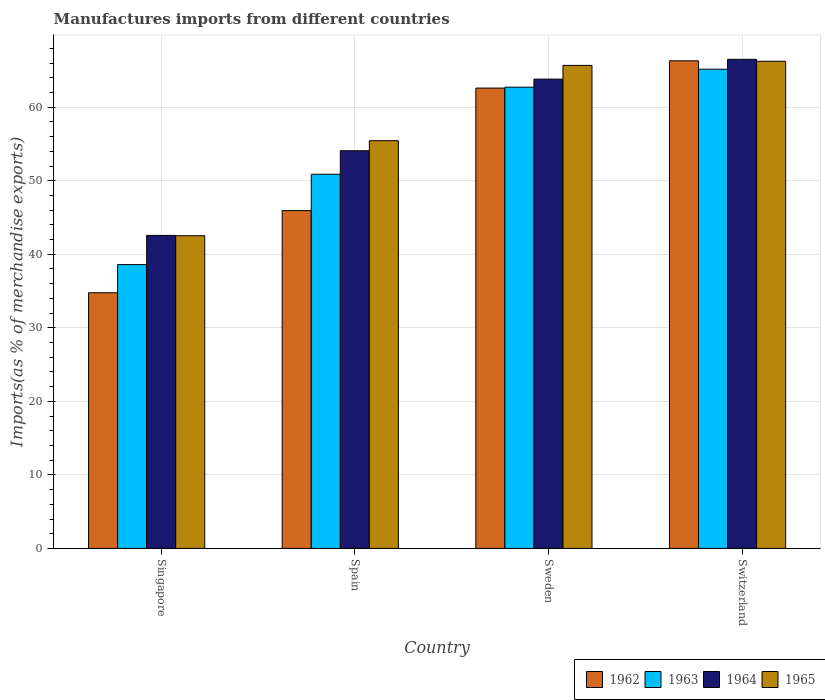How many different coloured bars are there?
Give a very brief answer. 4. How many groups of bars are there?
Your answer should be very brief. 4. Are the number of bars per tick equal to the number of legend labels?
Provide a succinct answer. Yes. How many bars are there on the 4th tick from the left?
Give a very brief answer. 4. How many bars are there on the 4th tick from the right?
Your answer should be compact. 4. What is the label of the 4th group of bars from the left?
Give a very brief answer. Switzerland. In how many cases, is the number of bars for a given country not equal to the number of legend labels?
Provide a short and direct response. 0. What is the percentage of imports to different countries in 1965 in Sweden?
Ensure brevity in your answer.  65.68. Across all countries, what is the maximum percentage of imports to different countries in 1962?
Make the answer very short. 66.31. Across all countries, what is the minimum percentage of imports to different countries in 1962?
Offer a terse response. 34.77. In which country was the percentage of imports to different countries in 1965 maximum?
Your response must be concise. Switzerland. In which country was the percentage of imports to different countries in 1964 minimum?
Ensure brevity in your answer.  Singapore. What is the total percentage of imports to different countries in 1963 in the graph?
Give a very brief answer. 217.37. What is the difference between the percentage of imports to different countries in 1963 in Spain and that in Switzerland?
Your answer should be compact. -14.28. What is the difference between the percentage of imports to different countries in 1964 in Singapore and the percentage of imports to different countries in 1963 in Spain?
Give a very brief answer. -8.32. What is the average percentage of imports to different countries in 1962 per country?
Keep it short and to the point. 52.4. What is the difference between the percentage of imports to different countries of/in 1965 and percentage of imports to different countries of/in 1964 in Singapore?
Your answer should be very brief. -0.04. In how many countries, is the percentage of imports to different countries in 1962 greater than 52 %?
Ensure brevity in your answer.  2. What is the ratio of the percentage of imports to different countries in 1962 in Singapore to that in Switzerland?
Your answer should be compact. 0.52. Is the percentage of imports to different countries in 1964 in Singapore less than that in Spain?
Offer a terse response. Yes. What is the difference between the highest and the second highest percentage of imports to different countries in 1964?
Make the answer very short. 12.43. What is the difference between the highest and the lowest percentage of imports to different countries in 1965?
Offer a very short reply. 23.72. In how many countries, is the percentage of imports to different countries in 1964 greater than the average percentage of imports to different countries in 1964 taken over all countries?
Your response must be concise. 2. Is the sum of the percentage of imports to different countries in 1964 in Singapore and Switzerland greater than the maximum percentage of imports to different countries in 1962 across all countries?
Provide a short and direct response. Yes. Is it the case that in every country, the sum of the percentage of imports to different countries in 1964 and percentage of imports to different countries in 1965 is greater than the sum of percentage of imports to different countries in 1963 and percentage of imports to different countries in 1962?
Your answer should be very brief. No. What does the 4th bar from the left in Sweden represents?
Offer a terse response. 1965. Are the values on the major ticks of Y-axis written in scientific E-notation?
Make the answer very short. No. How many legend labels are there?
Offer a terse response. 4. How are the legend labels stacked?
Provide a short and direct response. Horizontal. What is the title of the graph?
Make the answer very short. Manufactures imports from different countries. Does "1961" appear as one of the legend labels in the graph?
Provide a short and direct response. No. What is the label or title of the Y-axis?
Provide a short and direct response. Imports(as % of merchandise exports). What is the Imports(as % of merchandise exports) of 1962 in Singapore?
Offer a terse response. 34.77. What is the Imports(as % of merchandise exports) of 1963 in Singapore?
Make the answer very short. 38.6. What is the Imports(as % of merchandise exports) of 1964 in Singapore?
Provide a succinct answer. 42.56. What is the Imports(as % of merchandise exports) of 1965 in Singapore?
Your answer should be compact. 42.52. What is the Imports(as % of merchandise exports) of 1962 in Spain?
Offer a very short reply. 45.94. What is the Imports(as % of merchandise exports) in 1963 in Spain?
Your answer should be compact. 50.88. What is the Imports(as % of merchandise exports) of 1964 in Spain?
Offer a very short reply. 54.08. What is the Imports(as % of merchandise exports) of 1965 in Spain?
Provide a short and direct response. 55.44. What is the Imports(as % of merchandise exports) of 1962 in Sweden?
Ensure brevity in your answer.  62.6. What is the Imports(as % of merchandise exports) of 1963 in Sweden?
Offer a terse response. 62.72. What is the Imports(as % of merchandise exports) of 1964 in Sweden?
Ensure brevity in your answer.  63.82. What is the Imports(as % of merchandise exports) of 1965 in Sweden?
Provide a succinct answer. 65.68. What is the Imports(as % of merchandise exports) in 1962 in Switzerland?
Ensure brevity in your answer.  66.31. What is the Imports(as % of merchandise exports) of 1963 in Switzerland?
Provide a short and direct response. 65.16. What is the Imports(as % of merchandise exports) of 1964 in Switzerland?
Give a very brief answer. 66.51. What is the Imports(as % of merchandise exports) in 1965 in Switzerland?
Your response must be concise. 66.24. Across all countries, what is the maximum Imports(as % of merchandise exports) of 1962?
Provide a short and direct response. 66.31. Across all countries, what is the maximum Imports(as % of merchandise exports) in 1963?
Your answer should be very brief. 65.16. Across all countries, what is the maximum Imports(as % of merchandise exports) in 1964?
Your response must be concise. 66.51. Across all countries, what is the maximum Imports(as % of merchandise exports) in 1965?
Keep it short and to the point. 66.24. Across all countries, what is the minimum Imports(as % of merchandise exports) in 1962?
Offer a very short reply. 34.77. Across all countries, what is the minimum Imports(as % of merchandise exports) in 1963?
Your response must be concise. 38.6. Across all countries, what is the minimum Imports(as % of merchandise exports) in 1964?
Offer a very short reply. 42.56. Across all countries, what is the minimum Imports(as % of merchandise exports) of 1965?
Make the answer very short. 42.52. What is the total Imports(as % of merchandise exports) in 1962 in the graph?
Provide a succinct answer. 209.61. What is the total Imports(as % of merchandise exports) of 1963 in the graph?
Your response must be concise. 217.37. What is the total Imports(as % of merchandise exports) in 1964 in the graph?
Offer a terse response. 226.97. What is the total Imports(as % of merchandise exports) of 1965 in the graph?
Offer a very short reply. 229.89. What is the difference between the Imports(as % of merchandise exports) of 1962 in Singapore and that in Spain?
Offer a very short reply. -11.17. What is the difference between the Imports(as % of merchandise exports) in 1963 in Singapore and that in Spain?
Provide a short and direct response. -12.29. What is the difference between the Imports(as % of merchandise exports) in 1964 in Singapore and that in Spain?
Ensure brevity in your answer.  -11.51. What is the difference between the Imports(as % of merchandise exports) of 1965 in Singapore and that in Spain?
Your answer should be compact. -12.92. What is the difference between the Imports(as % of merchandise exports) in 1962 in Singapore and that in Sweden?
Provide a succinct answer. -27.83. What is the difference between the Imports(as % of merchandise exports) of 1963 in Singapore and that in Sweden?
Your answer should be very brief. -24.13. What is the difference between the Imports(as % of merchandise exports) in 1964 in Singapore and that in Sweden?
Make the answer very short. -21.25. What is the difference between the Imports(as % of merchandise exports) in 1965 in Singapore and that in Sweden?
Make the answer very short. -23.16. What is the difference between the Imports(as % of merchandise exports) in 1962 in Singapore and that in Switzerland?
Provide a succinct answer. -31.54. What is the difference between the Imports(as % of merchandise exports) of 1963 in Singapore and that in Switzerland?
Offer a terse response. -26.57. What is the difference between the Imports(as % of merchandise exports) of 1964 in Singapore and that in Switzerland?
Give a very brief answer. -23.94. What is the difference between the Imports(as % of merchandise exports) of 1965 in Singapore and that in Switzerland?
Your response must be concise. -23.72. What is the difference between the Imports(as % of merchandise exports) in 1962 in Spain and that in Sweden?
Your answer should be very brief. -16.66. What is the difference between the Imports(as % of merchandise exports) in 1963 in Spain and that in Sweden?
Your answer should be compact. -11.84. What is the difference between the Imports(as % of merchandise exports) of 1964 in Spain and that in Sweden?
Provide a short and direct response. -9.74. What is the difference between the Imports(as % of merchandise exports) of 1965 in Spain and that in Sweden?
Keep it short and to the point. -10.24. What is the difference between the Imports(as % of merchandise exports) in 1962 in Spain and that in Switzerland?
Offer a very short reply. -20.37. What is the difference between the Imports(as % of merchandise exports) of 1963 in Spain and that in Switzerland?
Keep it short and to the point. -14.28. What is the difference between the Imports(as % of merchandise exports) of 1964 in Spain and that in Switzerland?
Provide a short and direct response. -12.43. What is the difference between the Imports(as % of merchandise exports) of 1965 in Spain and that in Switzerland?
Give a very brief answer. -10.8. What is the difference between the Imports(as % of merchandise exports) in 1962 in Sweden and that in Switzerland?
Keep it short and to the point. -3.71. What is the difference between the Imports(as % of merchandise exports) in 1963 in Sweden and that in Switzerland?
Ensure brevity in your answer.  -2.44. What is the difference between the Imports(as % of merchandise exports) of 1964 in Sweden and that in Switzerland?
Your answer should be compact. -2.69. What is the difference between the Imports(as % of merchandise exports) in 1965 in Sweden and that in Switzerland?
Keep it short and to the point. -0.56. What is the difference between the Imports(as % of merchandise exports) of 1962 in Singapore and the Imports(as % of merchandise exports) of 1963 in Spain?
Provide a succinct answer. -16.11. What is the difference between the Imports(as % of merchandise exports) in 1962 in Singapore and the Imports(as % of merchandise exports) in 1964 in Spain?
Give a very brief answer. -19.31. What is the difference between the Imports(as % of merchandise exports) of 1962 in Singapore and the Imports(as % of merchandise exports) of 1965 in Spain?
Give a very brief answer. -20.68. What is the difference between the Imports(as % of merchandise exports) of 1963 in Singapore and the Imports(as % of merchandise exports) of 1964 in Spain?
Ensure brevity in your answer.  -15.48. What is the difference between the Imports(as % of merchandise exports) in 1963 in Singapore and the Imports(as % of merchandise exports) in 1965 in Spain?
Ensure brevity in your answer.  -16.85. What is the difference between the Imports(as % of merchandise exports) of 1964 in Singapore and the Imports(as % of merchandise exports) of 1965 in Spain?
Make the answer very short. -12.88. What is the difference between the Imports(as % of merchandise exports) of 1962 in Singapore and the Imports(as % of merchandise exports) of 1963 in Sweden?
Your answer should be very brief. -27.95. What is the difference between the Imports(as % of merchandise exports) of 1962 in Singapore and the Imports(as % of merchandise exports) of 1964 in Sweden?
Make the answer very short. -29.05. What is the difference between the Imports(as % of merchandise exports) of 1962 in Singapore and the Imports(as % of merchandise exports) of 1965 in Sweden?
Your response must be concise. -30.91. What is the difference between the Imports(as % of merchandise exports) of 1963 in Singapore and the Imports(as % of merchandise exports) of 1964 in Sweden?
Your response must be concise. -25.22. What is the difference between the Imports(as % of merchandise exports) in 1963 in Singapore and the Imports(as % of merchandise exports) in 1965 in Sweden?
Your answer should be compact. -27.09. What is the difference between the Imports(as % of merchandise exports) of 1964 in Singapore and the Imports(as % of merchandise exports) of 1965 in Sweden?
Give a very brief answer. -23.12. What is the difference between the Imports(as % of merchandise exports) of 1962 in Singapore and the Imports(as % of merchandise exports) of 1963 in Switzerland?
Provide a succinct answer. -30.4. What is the difference between the Imports(as % of merchandise exports) in 1962 in Singapore and the Imports(as % of merchandise exports) in 1964 in Switzerland?
Offer a very short reply. -31.74. What is the difference between the Imports(as % of merchandise exports) of 1962 in Singapore and the Imports(as % of merchandise exports) of 1965 in Switzerland?
Keep it short and to the point. -31.48. What is the difference between the Imports(as % of merchandise exports) of 1963 in Singapore and the Imports(as % of merchandise exports) of 1964 in Switzerland?
Provide a short and direct response. -27.91. What is the difference between the Imports(as % of merchandise exports) in 1963 in Singapore and the Imports(as % of merchandise exports) in 1965 in Switzerland?
Give a very brief answer. -27.65. What is the difference between the Imports(as % of merchandise exports) in 1964 in Singapore and the Imports(as % of merchandise exports) in 1965 in Switzerland?
Ensure brevity in your answer.  -23.68. What is the difference between the Imports(as % of merchandise exports) of 1962 in Spain and the Imports(as % of merchandise exports) of 1963 in Sweden?
Provide a short and direct response. -16.78. What is the difference between the Imports(as % of merchandise exports) in 1962 in Spain and the Imports(as % of merchandise exports) in 1964 in Sweden?
Your response must be concise. -17.88. What is the difference between the Imports(as % of merchandise exports) in 1962 in Spain and the Imports(as % of merchandise exports) in 1965 in Sweden?
Ensure brevity in your answer.  -19.74. What is the difference between the Imports(as % of merchandise exports) of 1963 in Spain and the Imports(as % of merchandise exports) of 1964 in Sweden?
Keep it short and to the point. -12.94. What is the difference between the Imports(as % of merchandise exports) of 1963 in Spain and the Imports(as % of merchandise exports) of 1965 in Sweden?
Make the answer very short. -14.8. What is the difference between the Imports(as % of merchandise exports) of 1964 in Spain and the Imports(as % of merchandise exports) of 1965 in Sweden?
Your response must be concise. -11.6. What is the difference between the Imports(as % of merchandise exports) in 1962 in Spain and the Imports(as % of merchandise exports) in 1963 in Switzerland?
Give a very brief answer. -19.23. What is the difference between the Imports(as % of merchandise exports) of 1962 in Spain and the Imports(as % of merchandise exports) of 1964 in Switzerland?
Your answer should be very brief. -20.57. What is the difference between the Imports(as % of merchandise exports) of 1962 in Spain and the Imports(as % of merchandise exports) of 1965 in Switzerland?
Ensure brevity in your answer.  -20.31. What is the difference between the Imports(as % of merchandise exports) in 1963 in Spain and the Imports(as % of merchandise exports) in 1964 in Switzerland?
Provide a short and direct response. -15.63. What is the difference between the Imports(as % of merchandise exports) in 1963 in Spain and the Imports(as % of merchandise exports) in 1965 in Switzerland?
Provide a short and direct response. -15.36. What is the difference between the Imports(as % of merchandise exports) of 1964 in Spain and the Imports(as % of merchandise exports) of 1965 in Switzerland?
Make the answer very short. -12.17. What is the difference between the Imports(as % of merchandise exports) of 1962 in Sweden and the Imports(as % of merchandise exports) of 1963 in Switzerland?
Your response must be concise. -2.57. What is the difference between the Imports(as % of merchandise exports) of 1962 in Sweden and the Imports(as % of merchandise exports) of 1964 in Switzerland?
Offer a terse response. -3.91. What is the difference between the Imports(as % of merchandise exports) of 1962 in Sweden and the Imports(as % of merchandise exports) of 1965 in Switzerland?
Your response must be concise. -3.65. What is the difference between the Imports(as % of merchandise exports) in 1963 in Sweden and the Imports(as % of merchandise exports) in 1964 in Switzerland?
Your response must be concise. -3.78. What is the difference between the Imports(as % of merchandise exports) in 1963 in Sweden and the Imports(as % of merchandise exports) in 1965 in Switzerland?
Keep it short and to the point. -3.52. What is the difference between the Imports(as % of merchandise exports) in 1964 in Sweden and the Imports(as % of merchandise exports) in 1965 in Switzerland?
Give a very brief answer. -2.43. What is the average Imports(as % of merchandise exports) in 1962 per country?
Give a very brief answer. 52.4. What is the average Imports(as % of merchandise exports) of 1963 per country?
Your answer should be very brief. 54.34. What is the average Imports(as % of merchandise exports) of 1964 per country?
Give a very brief answer. 56.74. What is the average Imports(as % of merchandise exports) of 1965 per country?
Provide a short and direct response. 57.47. What is the difference between the Imports(as % of merchandise exports) in 1962 and Imports(as % of merchandise exports) in 1963 in Singapore?
Ensure brevity in your answer.  -3.83. What is the difference between the Imports(as % of merchandise exports) in 1962 and Imports(as % of merchandise exports) in 1964 in Singapore?
Offer a very short reply. -7.8. What is the difference between the Imports(as % of merchandise exports) of 1962 and Imports(as % of merchandise exports) of 1965 in Singapore?
Your answer should be compact. -7.75. What is the difference between the Imports(as % of merchandise exports) of 1963 and Imports(as % of merchandise exports) of 1964 in Singapore?
Your response must be concise. -3.97. What is the difference between the Imports(as % of merchandise exports) of 1963 and Imports(as % of merchandise exports) of 1965 in Singapore?
Ensure brevity in your answer.  -3.93. What is the difference between the Imports(as % of merchandise exports) in 1964 and Imports(as % of merchandise exports) in 1965 in Singapore?
Offer a terse response. 0.04. What is the difference between the Imports(as % of merchandise exports) of 1962 and Imports(as % of merchandise exports) of 1963 in Spain?
Ensure brevity in your answer.  -4.94. What is the difference between the Imports(as % of merchandise exports) of 1962 and Imports(as % of merchandise exports) of 1964 in Spain?
Offer a very short reply. -8.14. What is the difference between the Imports(as % of merchandise exports) in 1962 and Imports(as % of merchandise exports) in 1965 in Spain?
Ensure brevity in your answer.  -9.51. What is the difference between the Imports(as % of merchandise exports) of 1963 and Imports(as % of merchandise exports) of 1964 in Spain?
Give a very brief answer. -3.2. What is the difference between the Imports(as % of merchandise exports) in 1963 and Imports(as % of merchandise exports) in 1965 in Spain?
Your response must be concise. -4.56. What is the difference between the Imports(as % of merchandise exports) of 1964 and Imports(as % of merchandise exports) of 1965 in Spain?
Give a very brief answer. -1.37. What is the difference between the Imports(as % of merchandise exports) of 1962 and Imports(as % of merchandise exports) of 1963 in Sweden?
Ensure brevity in your answer.  -0.12. What is the difference between the Imports(as % of merchandise exports) of 1962 and Imports(as % of merchandise exports) of 1964 in Sweden?
Offer a very short reply. -1.22. What is the difference between the Imports(as % of merchandise exports) of 1962 and Imports(as % of merchandise exports) of 1965 in Sweden?
Offer a very short reply. -3.08. What is the difference between the Imports(as % of merchandise exports) in 1963 and Imports(as % of merchandise exports) in 1964 in Sweden?
Your answer should be very brief. -1.09. What is the difference between the Imports(as % of merchandise exports) in 1963 and Imports(as % of merchandise exports) in 1965 in Sweden?
Give a very brief answer. -2.96. What is the difference between the Imports(as % of merchandise exports) in 1964 and Imports(as % of merchandise exports) in 1965 in Sweden?
Offer a very short reply. -1.87. What is the difference between the Imports(as % of merchandise exports) of 1962 and Imports(as % of merchandise exports) of 1963 in Switzerland?
Provide a short and direct response. 1.14. What is the difference between the Imports(as % of merchandise exports) in 1962 and Imports(as % of merchandise exports) in 1964 in Switzerland?
Make the answer very short. -0.2. What is the difference between the Imports(as % of merchandise exports) of 1962 and Imports(as % of merchandise exports) of 1965 in Switzerland?
Ensure brevity in your answer.  0.06. What is the difference between the Imports(as % of merchandise exports) of 1963 and Imports(as % of merchandise exports) of 1964 in Switzerland?
Provide a succinct answer. -1.34. What is the difference between the Imports(as % of merchandise exports) in 1963 and Imports(as % of merchandise exports) in 1965 in Switzerland?
Your response must be concise. -1.08. What is the difference between the Imports(as % of merchandise exports) of 1964 and Imports(as % of merchandise exports) of 1965 in Switzerland?
Offer a very short reply. 0.26. What is the ratio of the Imports(as % of merchandise exports) of 1962 in Singapore to that in Spain?
Your answer should be very brief. 0.76. What is the ratio of the Imports(as % of merchandise exports) in 1963 in Singapore to that in Spain?
Offer a very short reply. 0.76. What is the ratio of the Imports(as % of merchandise exports) in 1964 in Singapore to that in Spain?
Your answer should be compact. 0.79. What is the ratio of the Imports(as % of merchandise exports) of 1965 in Singapore to that in Spain?
Offer a terse response. 0.77. What is the ratio of the Imports(as % of merchandise exports) of 1962 in Singapore to that in Sweden?
Provide a short and direct response. 0.56. What is the ratio of the Imports(as % of merchandise exports) in 1963 in Singapore to that in Sweden?
Provide a succinct answer. 0.62. What is the ratio of the Imports(as % of merchandise exports) in 1964 in Singapore to that in Sweden?
Provide a succinct answer. 0.67. What is the ratio of the Imports(as % of merchandise exports) in 1965 in Singapore to that in Sweden?
Provide a succinct answer. 0.65. What is the ratio of the Imports(as % of merchandise exports) of 1962 in Singapore to that in Switzerland?
Provide a succinct answer. 0.52. What is the ratio of the Imports(as % of merchandise exports) of 1963 in Singapore to that in Switzerland?
Offer a terse response. 0.59. What is the ratio of the Imports(as % of merchandise exports) in 1964 in Singapore to that in Switzerland?
Ensure brevity in your answer.  0.64. What is the ratio of the Imports(as % of merchandise exports) of 1965 in Singapore to that in Switzerland?
Offer a terse response. 0.64. What is the ratio of the Imports(as % of merchandise exports) in 1962 in Spain to that in Sweden?
Offer a very short reply. 0.73. What is the ratio of the Imports(as % of merchandise exports) in 1963 in Spain to that in Sweden?
Keep it short and to the point. 0.81. What is the ratio of the Imports(as % of merchandise exports) of 1964 in Spain to that in Sweden?
Make the answer very short. 0.85. What is the ratio of the Imports(as % of merchandise exports) of 1965 in Spain to that in Sweden?
Give a very brief answer. 0.84. What is the ratio of the Imports(as % of merchandise exports) of 1962 in Spain to that in Switzerland?
Give a very brief answer. 0.69. What is the ratio of the Imports(as % of merchandise exports) in 1963 in Spain to that in Switzerland?
Keep it short and to the point. 0.78. What is the ratio of the Imports(as % of merchandise exports) in 1964 in Spain to that in Switzerland?
Make the answer very short. 0.81. What is the ratio of the Imports(as % of merchandise exports) in 1965 in Spain to that in Switzerland?
Offer a very short reply. 0.84. What is the ratio of the Imports(as % of merchandise exports) in 1962 in Sweden to that in Switzerland?
Offer a terse response. 0.94. What is the ratio of the Imports(as % of merchandise exports) in 1963 in Sweden to that in Switzerland?
Your answer should be compact. 0.96. What is the ratio of the Imports(as % of merchandise exports) of 1964 in Sweden to that in Switzerland?
Offer a very short reply. 0.96. What is the ratio of the Imports(as % of merchandise exports) in 1965 in Sweden to that in Switzerland?
Offer a very short reply. 0.99. What is the difference between the highest and the second highest Imports(as % of merchandise exports) in 1962?
Your answer should be very brief. 3.71. What is the difference between the highest and the second highest Imports(as % of merchandise exports) in 1963?
Provide a succinct answer. 2.44. What is the difference between the highest and the second highest Imports(as % of merchandise exports) of 1964?
Ensure brevity in your answer.  2.69. What is the difference between the highest and the second highest Imports(as % of merchandise exports) in 1965?
Your response must be concise. 0.56. What is the difference between the highest and the lowest Imports(as % of merchandise exports) of 1962?
Your answer should be very brief. 31.54. What is the difference between the highest and the lowest Imports(as % of merchandise exports) in 1963?
Make the answer very short. 26.57. What is the difference between the highest and the lowest Imports(as % of merchandise exports) in 1964?
Keep it short and to the point. 23.94. What is the difference between the highest and the lowest Imports(as % of merchandise exports) in 1965?
Make the answer very short. 23.72. 